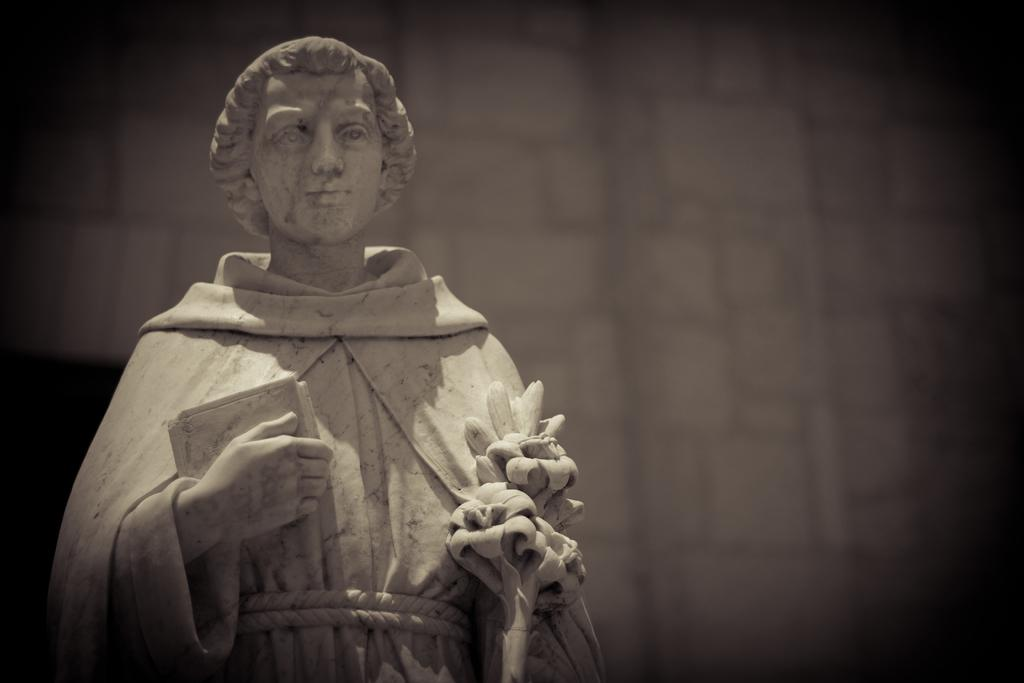What is the main subject of the image? There is a person statue in the image. What is the statue holding in its hands? The statue is holding a book and flowers in its hands. What can be seen behind the statue? There is a wall behind the statue. How many chairs are visible in the image? There are no chairs visible in the image; it features a person statue holding a book and flowers with a wall in the background. 